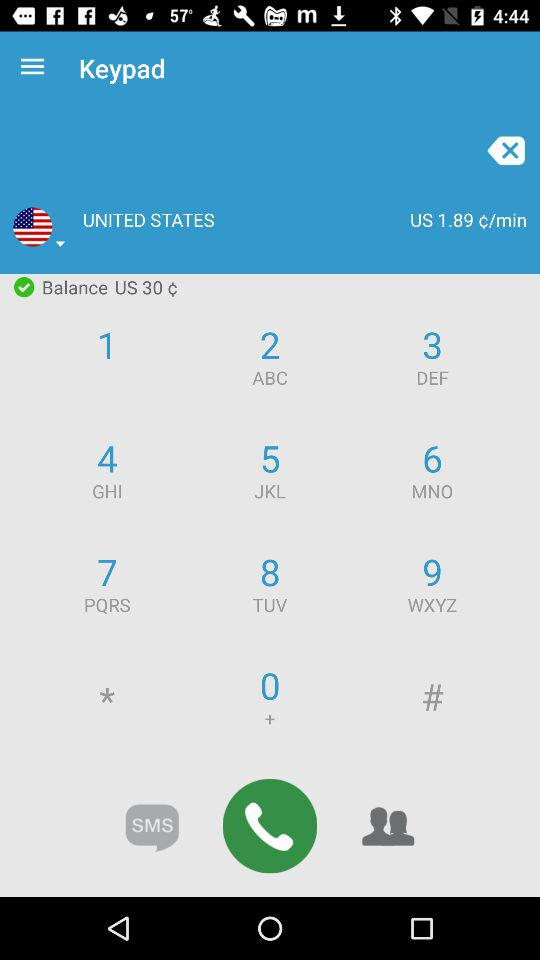What is the call cost per minute in the United States? The call cost per minute in the United States is 1.89 ¢. 